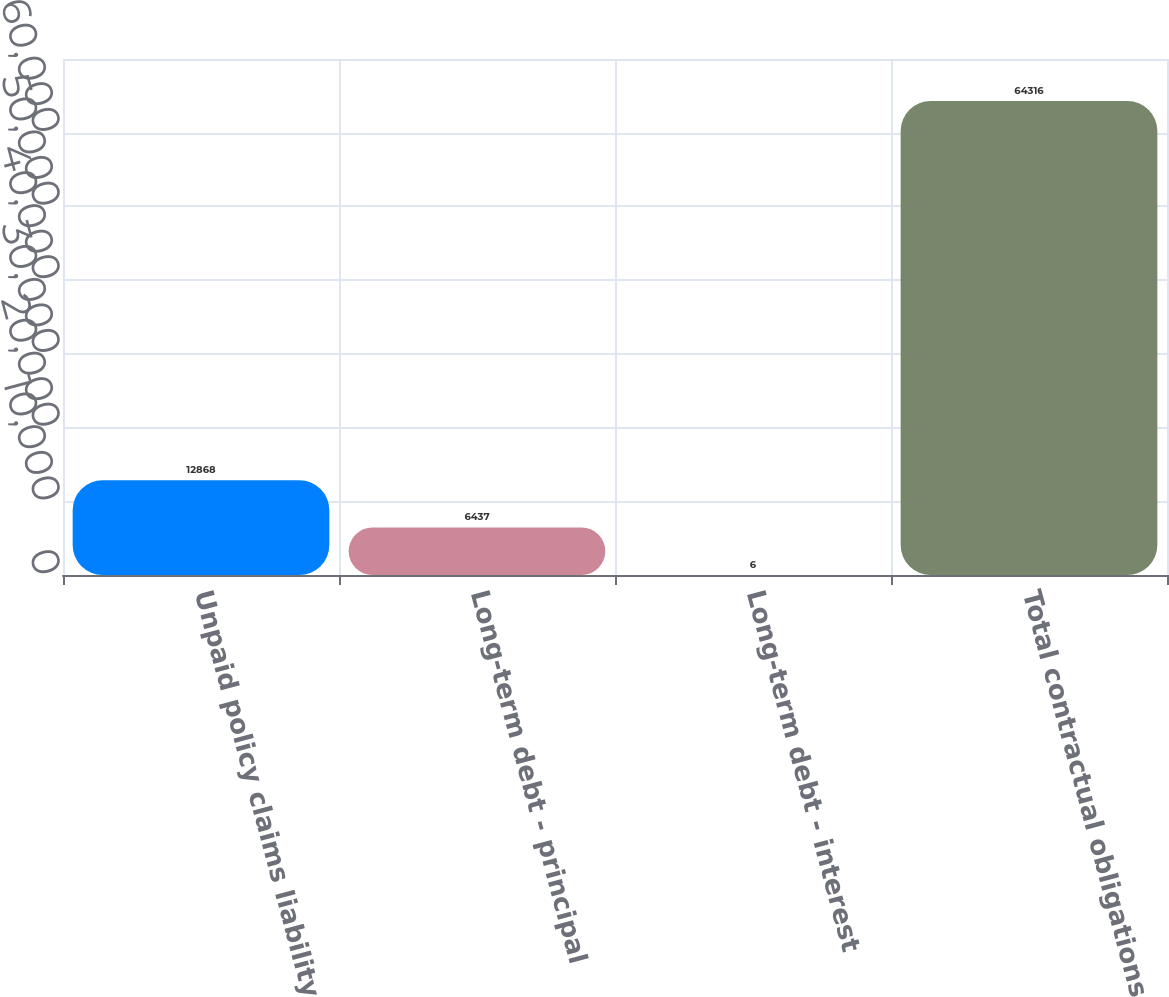Convert chart to OTSL. <chart><loc_0><loc_0><loc_500><loc_500><bar_chart><fcel>Unpaid policy claims liability<fcel>Long-term debt - principal<fcel>Long-term debt - interest<fcel>Total contractual obligations<nl><fcel>12868<fcel>6437<fcel>6<fcel>64316<nl></chart> 